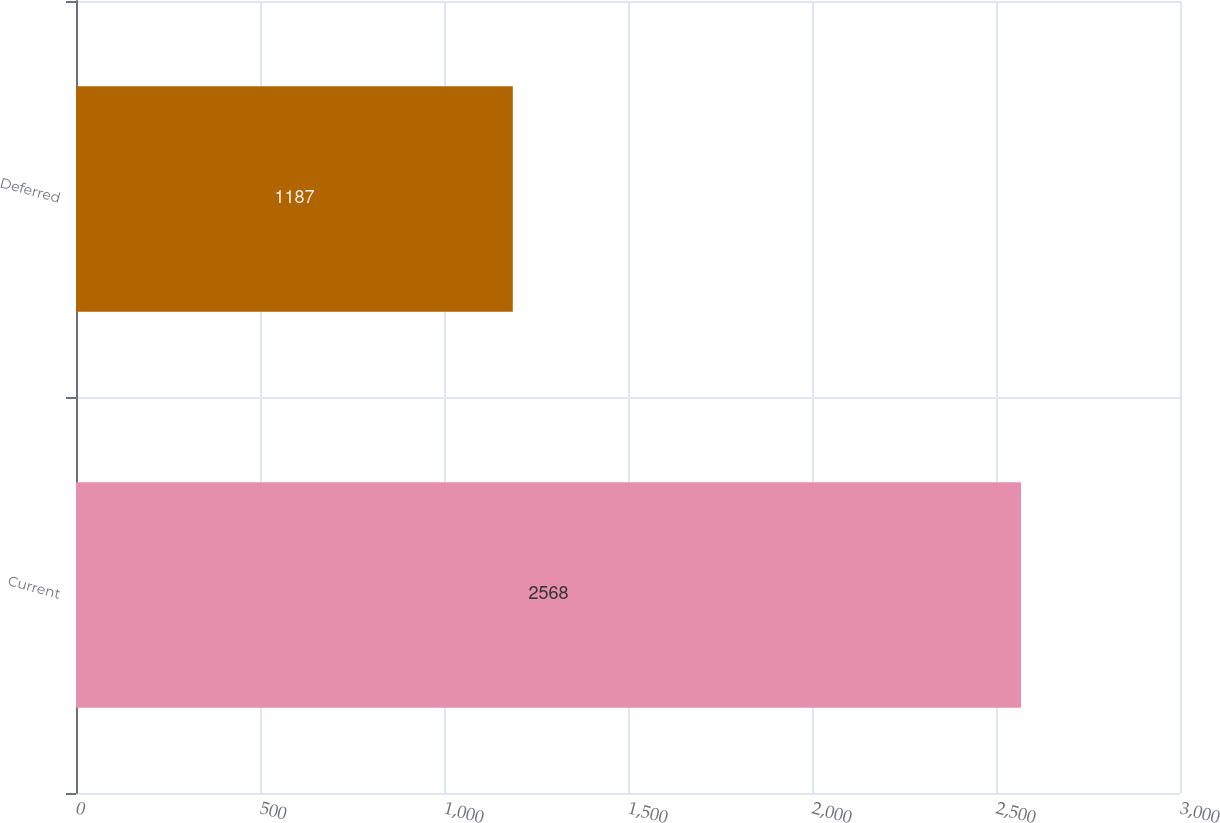Convert chart to OTSL. <chart><loc_0><loc_0><loc_500><loc_500><bar_chart><fcel>Current<fcel>Deferred<nl><fcel>2568<fcel>1187<nl></chart> 